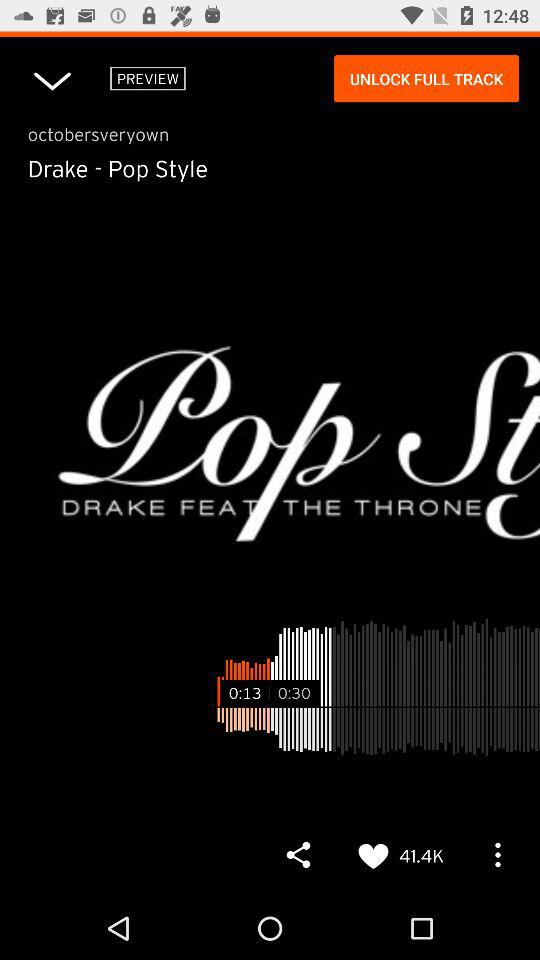How many more seconds is the song than the preview?
Answer the question using a single word or phrase. 17 